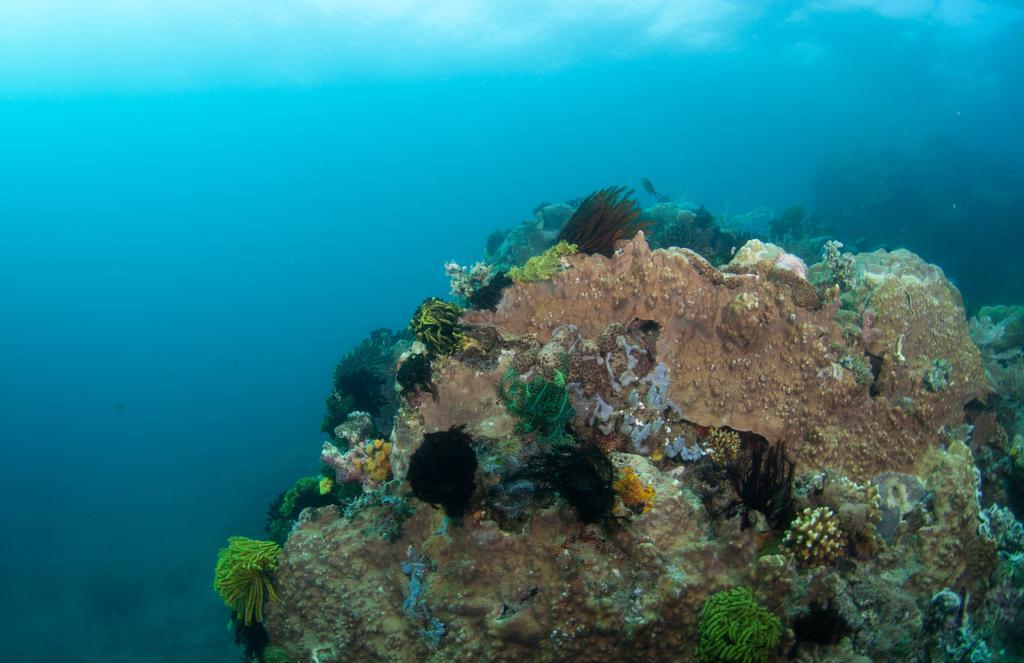In one or two sentences, can you explain what this image depicts? In this image there a few sea plants and some algae in the water. 